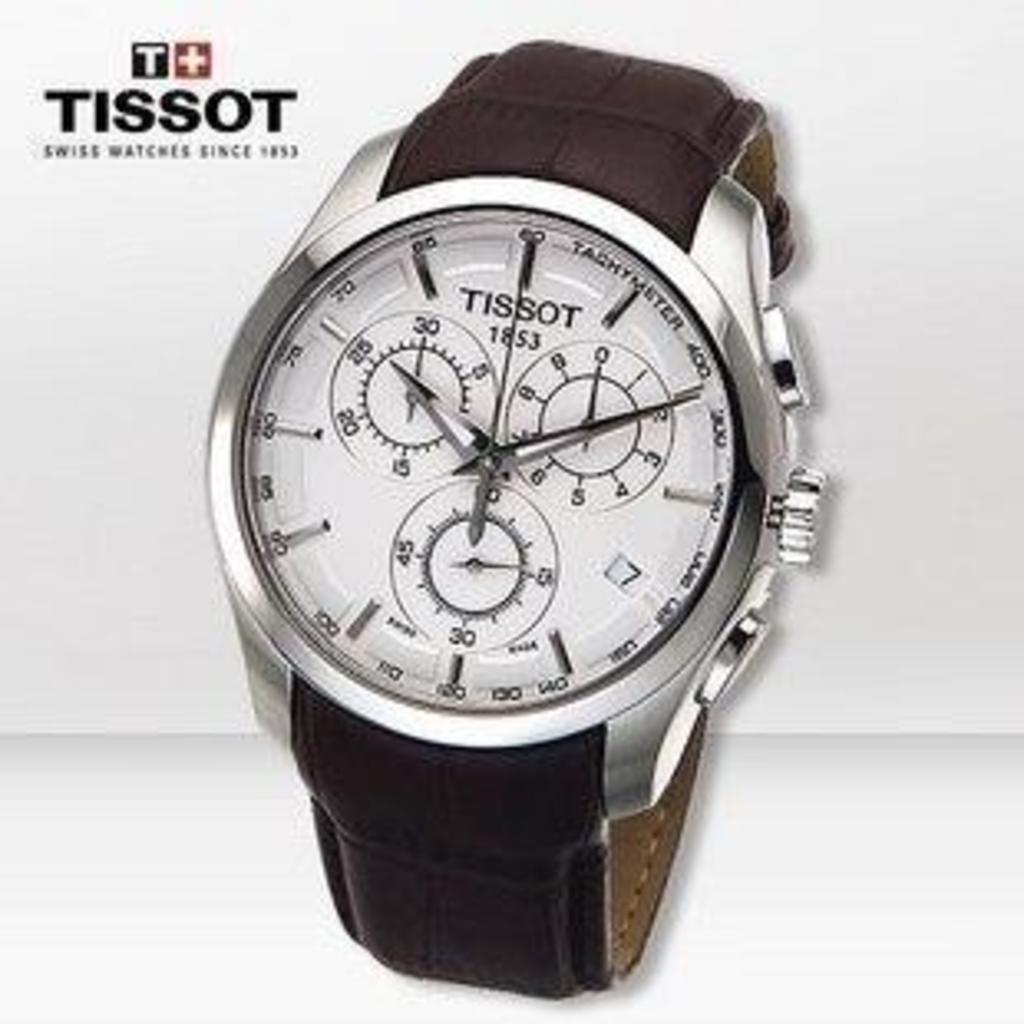<image>
Summarize the visual content of the image. A Tissot watch is displayed in an advertisement. 